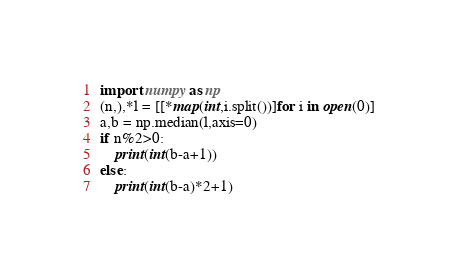Convert code to text. <code><loc_0><loc_0><loc_500><loc_500><_Python_>import numpy as np
(n,),*l = [[*map(int,i.split())]for i in open(0)]
a,b = np.median(l,axis=0)
if n%2>0:
    print(int(b-a+1))
else:
    print(int(b-a)*2+1)</code> 